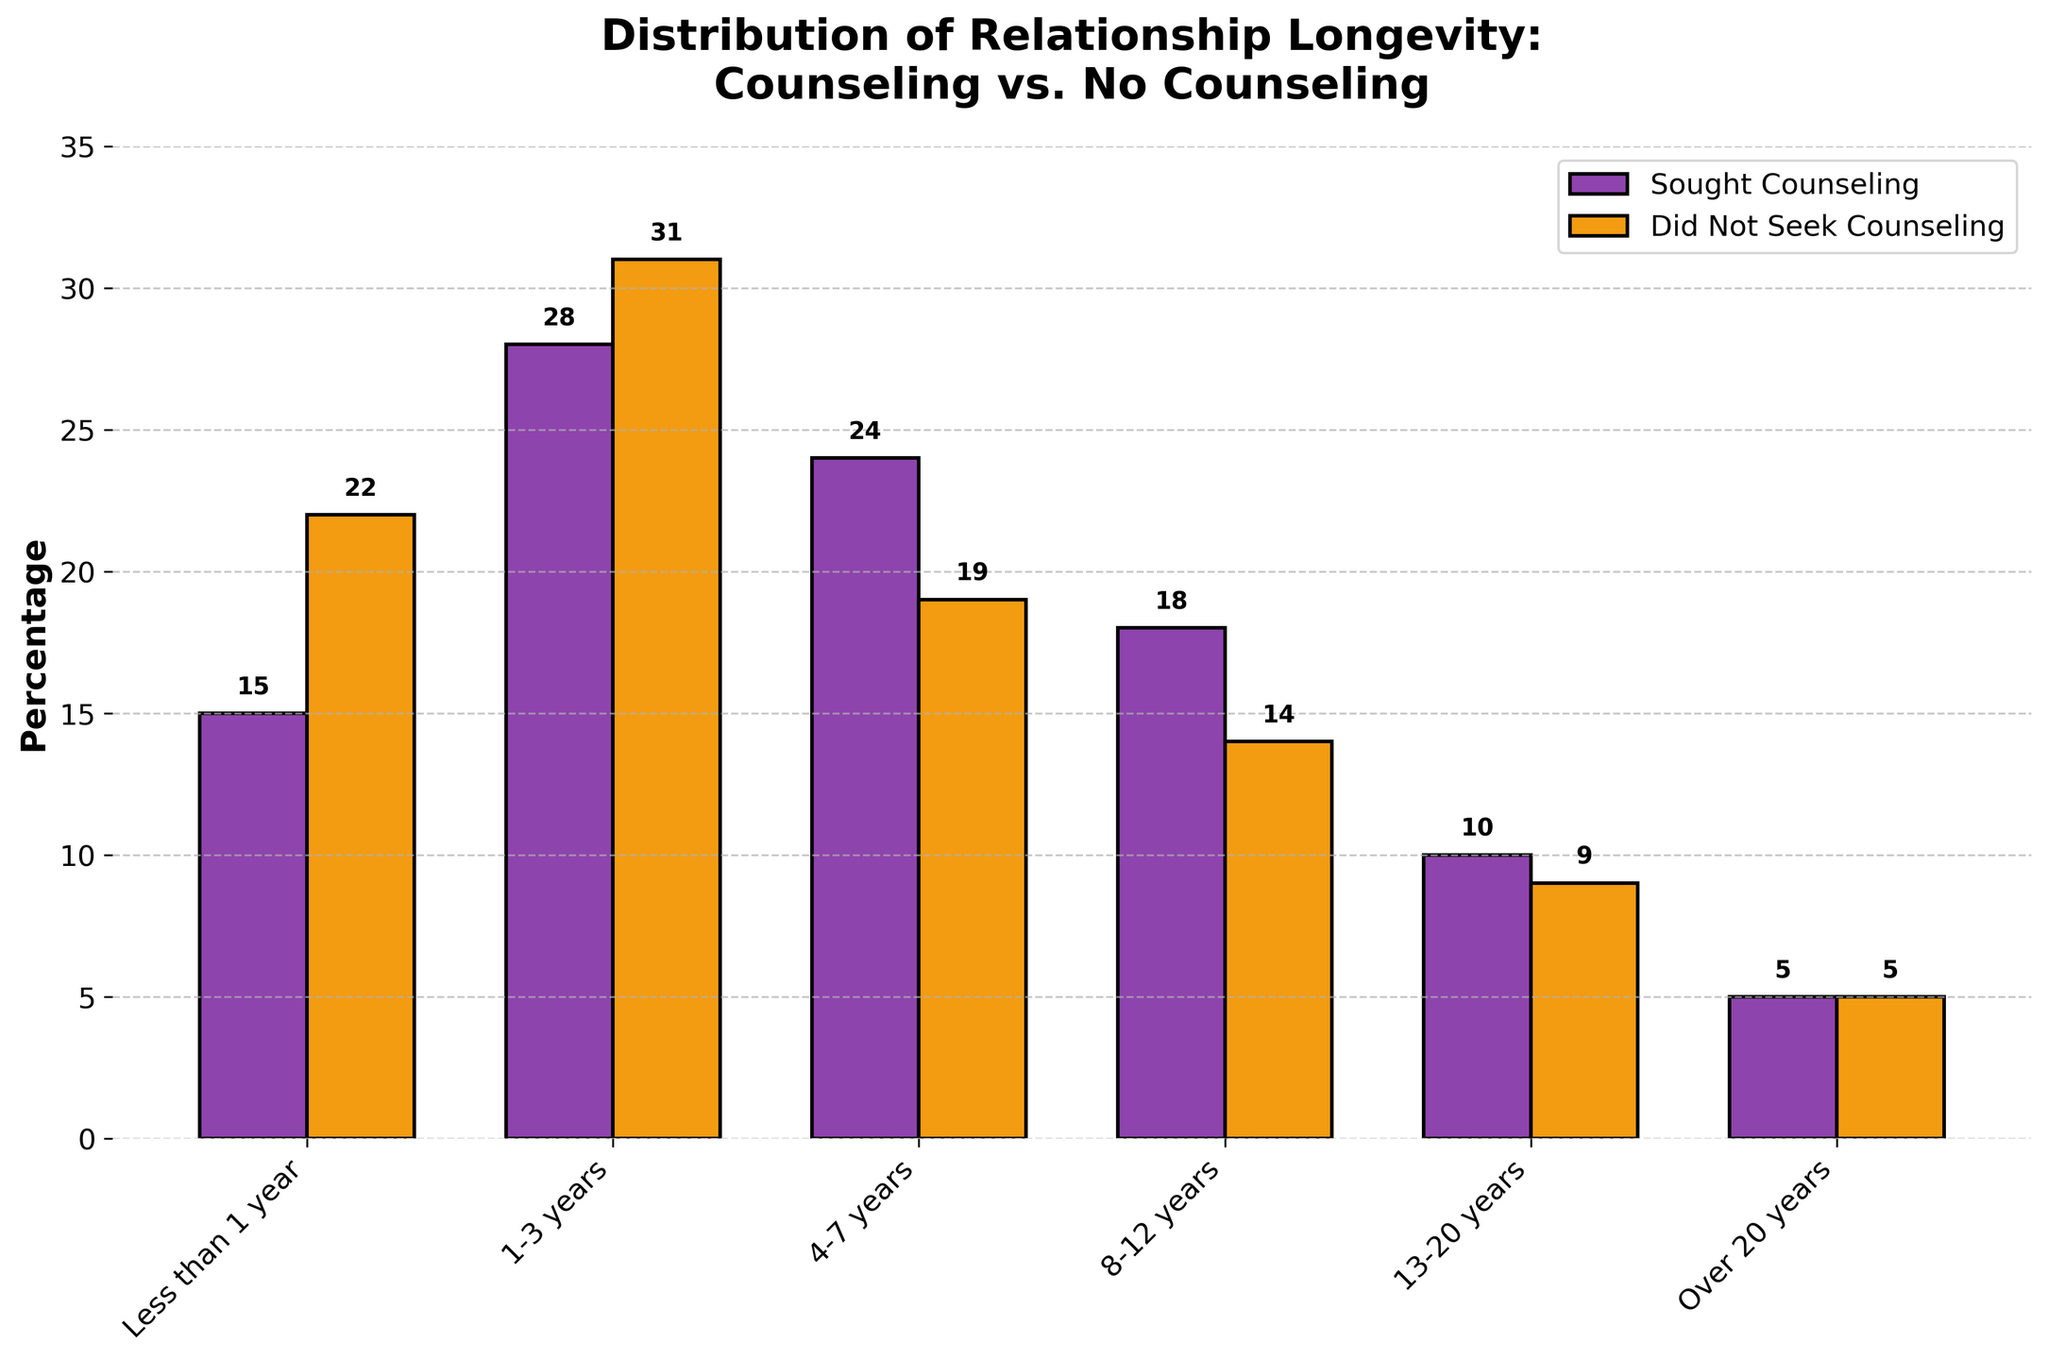What is the percentage difference in the "Less than 1 year" category between those who sought counseling and those who did not? The percentage for "Sought Counseling" in the "Less than 1 year" category is 15%, and for "Did Not Seek Counseling" it is 22%. The difference is calculated as 22% - 15% = 7%.
Answer: 7% Which group has a higher percentage in the 8-12 years category? The percentage for "Sought Counseling" in the "8-12 years" category is 18%, and for "Did Not Seek Counseling" it is 14%. Hence, the group that sought counseling has a higher percentage.
Answer: Sought Counseling What is the range (difference between max and min values) of percentages for the couples who sought counseling? The percentages for couples who sought counseling are 15%, 28%, 24%, 18%, 10%, and 5%. The maximum value is 28% and the minimum value is 5%, so the range is 28% - 5% = 23%.
Answer: 23% How many categories have a higher percentage of couples who did not seek counseling compared to those that did? By inspecting the bar chart, the categories where "Did Not Seek Counseling" percentage is higher are "Less than 1 year" (22% vs. 15%) and "1-3 years" (31% vs. 28%). Thus, there are 2 such categories.
Answer: 2 In which relationship duration category is the difference in percentage smallest between the two groups? The categories and their differences: 
Less than 1 year (22% - 15% = 7%), 
1-3 years (31% - 28% = 3%),
4-7 years (24% - 19% = 5%),
8-12 years (18% - 14% = 4%), 
13-20 years (10% - 9% = 1%), 
Over 20 years (5% - 5% = 0%). 
The smallest difference is in the "Over 20 years" category where the difference is 0%.
Answer: Over 20 years What is the total combined percentage for couples who did not seek counseling in the "4-7 years" and "8-12 years" categories? For "4-7 years" the percentage is 19%, and for "8-12 years" the percentage is 14%. The combined total is 19% + 14% = 33%.
Answer: 33% Which category shows an equal percentage for both groups? In the "Over 20 years" category, both "Sought Counseling" and "Did Not Seek Counseling" have a percentage of 5%.
Answer: Over 20 years What is the average percentage of couples who sought counseling across all categories? The percentages for couples who sought counseling are 15%, 28%, 24%, 18%, 10%, and 5%. The sum is 15 + 28 + 24 + 18 + 10 + 5 = 100. There are 6 categories, so the average is 100 / 6 ≈ 16.67%.
Answer: 16.67% Between the "1-3 years" and "4-7 years" categories, which shows a greater disparity in percentages between those who sought counseling and those who did not? For "1-3 years," the difference is 31% - 28% = 3%. For "4-7 years," the difference is 24% - 19% = 5%. Therefore, "4-7 years" shows a greater disparity.
Answer: 4-7 years 